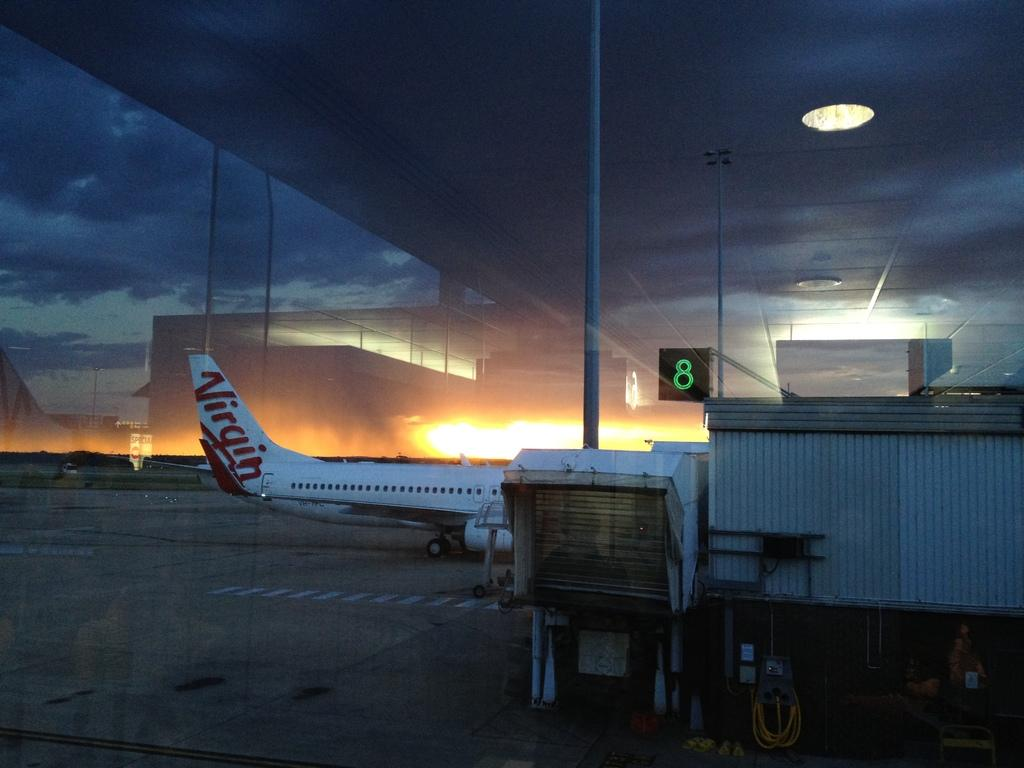What is the main subject of the image? The main subject of the image is an aircraft. What else can be seen in the image besides the aircraft? There are objects, buildings, poles, lights, and the sky visible in the image. Can you describe the poles in the image? The poles are vertical structures that can be seen in the image. What is the condition of the sky in the image? The sky is visible in the image. How many chairs are present in the image? There are no chairs visible in the image. What shape is the aircraft in the image? The provided facts do not mention the shape of the aircraft, so it cannot be determined from the image. 